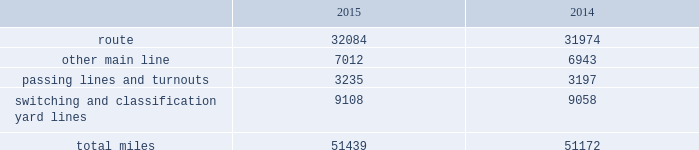Item 1b .
Unresolved staff comments item 2 .
Properties we employ a variety of assets in the management and operation of our rail business .
Our rail network covers 23 states in the western two-thirds of the u.s .
Our rail network includes 32084 route miles .
We own 26064 miles and operate on the remainder pursuant to trackage rights or leases .
The table describes track miles at december 31 , 2015 and 2014. .
Headquarters building we own our headquarters building in omaha , nebraska .
The facility has 1.2 million square feet of space for approximately 4000 employees. .
What percentage of total miles were other main line in 2015? 
Computations: (7012 / 51439)
Answer: 0.13632. 